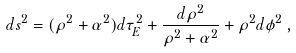<formula> <loc_0><loc_0><loc_500><loc_500>d s ^ { 2 } = ( \rho ^ { 2 } + \alpha ^ { 2 } ) d \tau _ { E } ^ { 2 } + \frac { d \rho ^ { 2 } } { \rho ^ { 2 } + \alpha ^ { 2 } } + \rho ^ { 2 } d \phi ^ { 2 } \, ,</formula> 